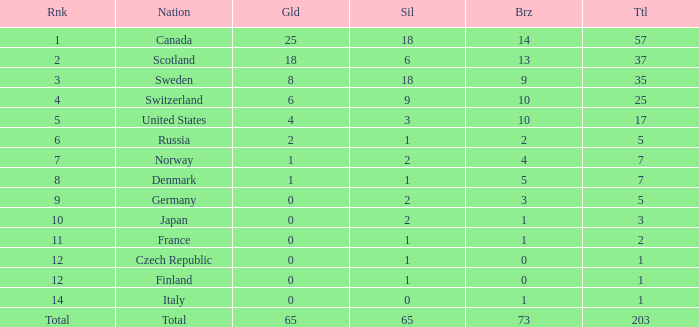What is the number of bronze medals when the total is greater than 1, more than 2 silver medals are won, and the rank is 2? 13.0. 